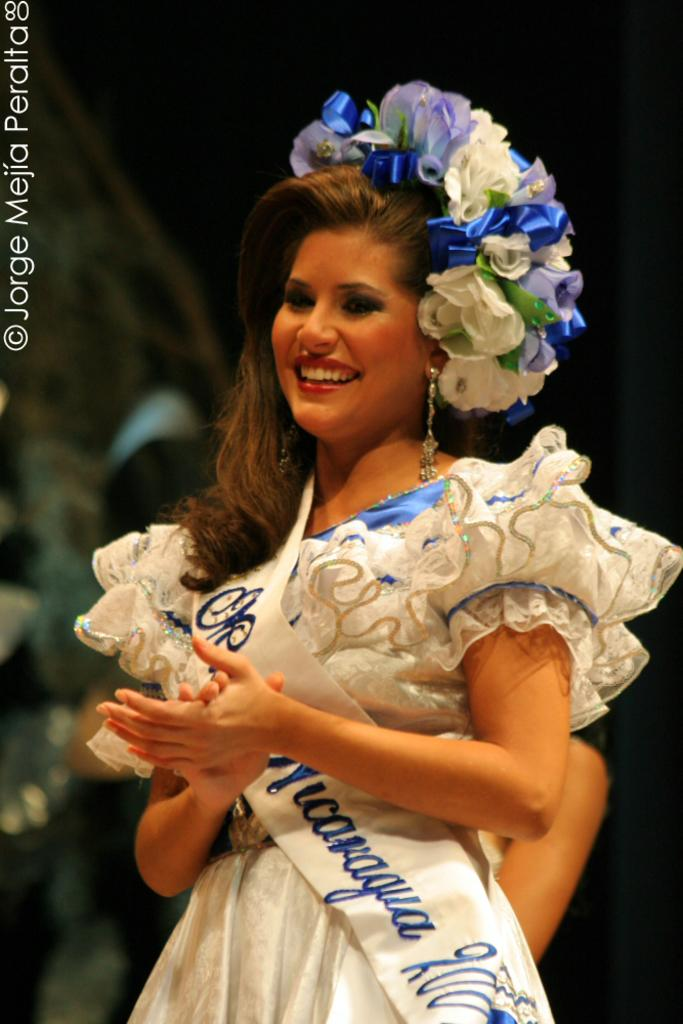<image>
Give a short and clear explanation of the subsequent image. A woman wearing a sash that says Nicaragua has a flowered headdress on. 